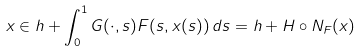<formula> <loc_0><loc_0><loc_500><loc_500>x \in h + \int _ { 0 } ^ { 1 } G ( \cdot , s ) F ( s , x ( s ) ) \, d s = h + H \circ N _ { F } ( x )</formula> 